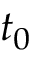Convert formula to latex. <formula><loc_0><loc_0><loc_500><loc_500>t _ { 0 }</formula> 